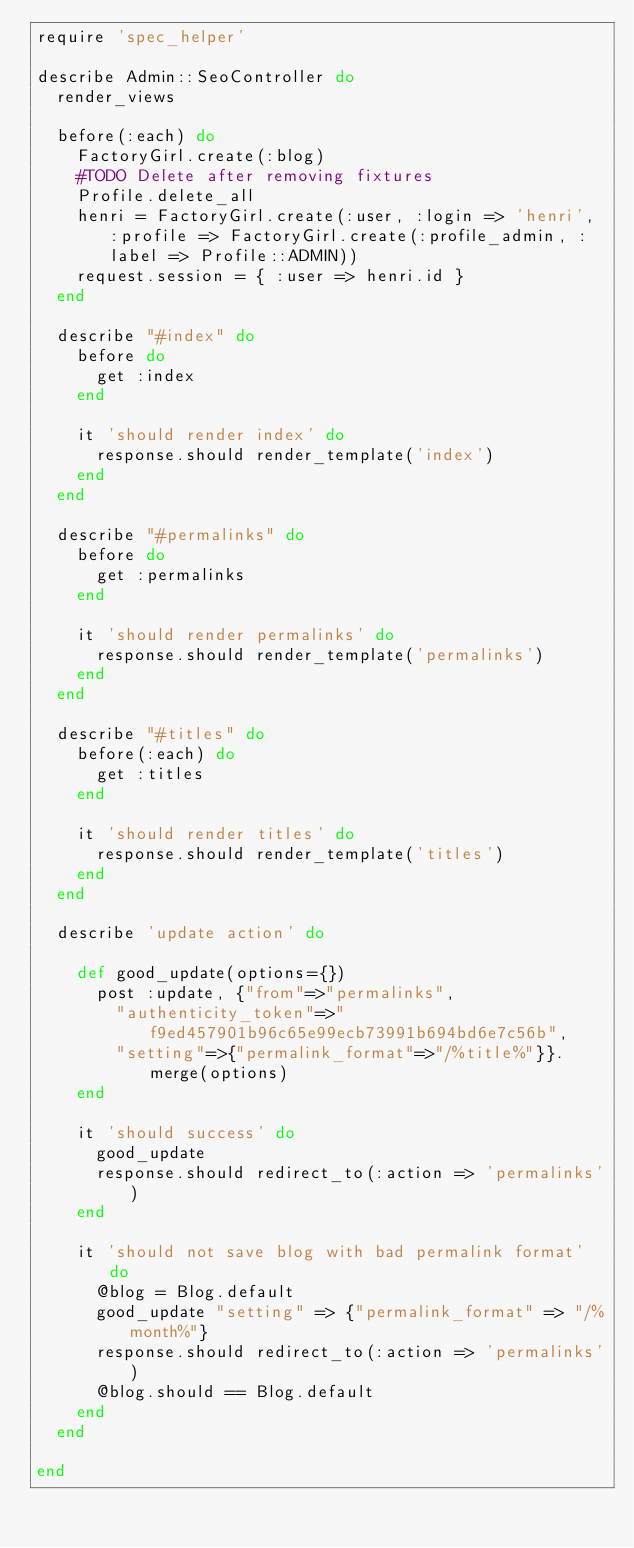<code> <loc_0><loc_0><loc_500><loc_500><_Ruby_>require 'spec_helper'

describe Admin::SeoController do
  render_views

  before(:each) do
    FactoryGirl.create(:blog)
    #TODO Delete after removing fixtures
    Profile.delete_all
    henri = FactoryGirl.create(:user, :login => 'henri', :profile => FactoryGirl.create(:profile_admin, :label => Profile::ADMIN))
    request.session = { :user => henri.id }
  end

  describe "#index" do
    before do
      get :index
    end

    it 'should render index' do
      response.should render_template('index')
    end    
  end

  describe "#permalinks" do
    before do
      get :permalinks
    end

    it 'should render permalinks' do
      response.should render_template('permalinks')
    end
  end

  describe "#titles" do
    before(:each) do
      get :titles
    end
    
    it 'should render titles' do
      response.should render_template('titles')
    end    
  end

  describe 'update action' do

    def good_update(options={})
      post :update, {"from"=>"permalinks",
        "authenticity_token"=>"f9ed457901b96c65e99ecb73991b694bd6e7c56b",
        "setting"=>{"permalink_format"=>"/%title%"}}.merge(options)
    end

    it 'should success' do
      good_update
      response.should redirect_to(:action => 'permalinks')
    end

    it 'should not save blog with bad permalink format' do
      @blog = Blog.default
      good_update "setting" => {"permalink_format" => "/%month%"}
      response.should redirect_to(:action => 'permalinks')
      @blog.should == Blog.default
    end
  end

end
</code> 